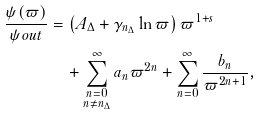Convert formula to latex. <formula><loc_0><loc_0><loc_500><loc_500>\frac { \psi ( \varpi ) } { \psi o u t } & = \left ( A _ { \Delta } + \gamma _ { n _ { \Delta } } \ln \varpi \right ) \varpi ^ { 1 + s } \\ & \quad + \sum _ { \substack { n = 0 \\ n \ne n _ { \Delta } } } ^ { \infty } { a _ { n } \varpi ^ { 2 n } } + \sum _ { n = 0 } ^ { \infty } { \frac { b _ { n } } { \varpi ^ { 2 n + 1 } } } ,</formula> 